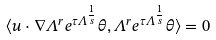Convert formula to latex. <formula><loc_0><loc_0><loc_500><loc_500>\langle u \cdot \nabla \Lambda ^ { r } e ^ { \tau \Lambda ^ { \frac { 1 } { s } } } \theta , \Lambda ^ { r } e ^ { \tau \Lambda ^ { \frac { 1 } { s } } } \theta \rangle = 0</formula> 